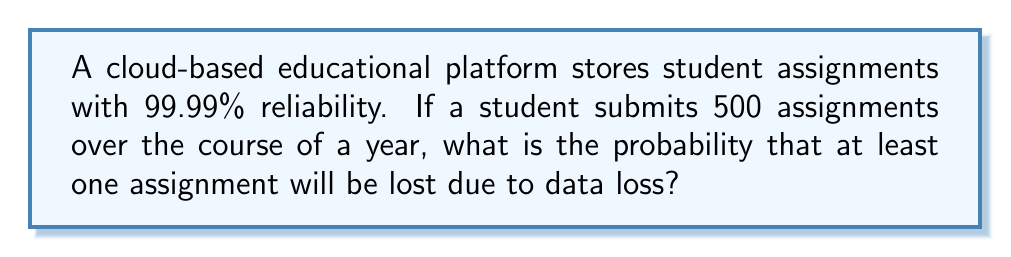What is the answer to this math problem? Let's approach this step-by-step:

1) First, we need to understand what 99.99% reliability means. It means that for each assignment, the probability of it being stored successfully is 0.9999, and consequently, the probability of data loss for a single assignment is:

   $p = 1 - 0.9999 = 0.0001$ or $0.01\%$

2) Now, we need to find the probability of at least one assignment being lost out of 500. It's easier to calculate the probability of no assignments being lost and then subtract that from 1.

3) The probability of no assignments being lost is the probability of all 500 assignments being stored successfully. This can be calculated as:

   $P(\text{no loss}) = (0.9999)^{500}$

4) We can calculate this using logarithms to handle the large exponent:

   $\log(P(\text{no loss})) = 500 \times \log(0.9999) = 500 \times (-0.0000434) = -0.0217$

   $P(\text{no loss}) = e^{-0.0217} \approx 0.9785$

5) Therefore, the probability of at least one assignment being lost is:

   $P(\text{at least one loss}) = 1 - P(\text{no loss}) = 1 - 0.9785 = 0.0215$

6) Converting to a percentage:

   $0.0215 \times 100\% = 2.15\%$
Answer: $2.15\%$ 